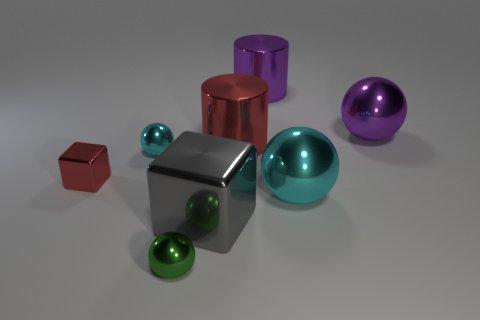Subtract all purple cylinders. How many cylinders are left? 1 Add 1 big blue rubber things. How many objects exist? 9 Subtract 1 spheres. How many spheres are left? 3 Subtract all small green matte cylinders. Subtract all gray cubes. How many objects are left? 7 Add 6 balls. How many balls are left? 10 Add 6 cyan shiny objects. How many cyan shiny objects exist? 8 Subtract 0 blue cylinders. How many objects are left? 8 Subtract all purple cylinders. Subtract all red balls. How many cylinders are left? 1 Subtract all cyan cubes. How many brown balls are left? 0 